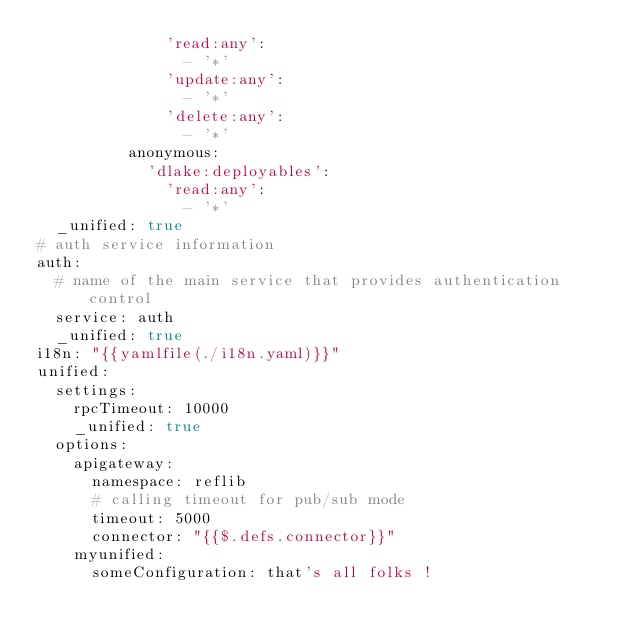Convert code to text. <code><loc_0><loc_0><loc_500><loc_500><_YAML_>              'read:any':
                - '*'
              'update:any':
                - '*'
              'delete:any':
                - '*'
          anonymous:
            'dlake:deployables':
              'read:any':
                - '*'
  _unified: true
# auth service information
auth:
  # name of the main service that provides authentication control
  service: auth
  _unified: true
i18n: "{{yamlfile(./i18n.yaml)}}"
unified:
  settings:
    rpcTimeout: 10000
    _unified: true
  options:
    apigateway:
      namespace: reflib
      # calling timeout for pub/sub mode
      timeout: 5000
      connector: "{{$.defs.connector}}"
    myunified:
      someConfiguration: that's all folks !
</code> 